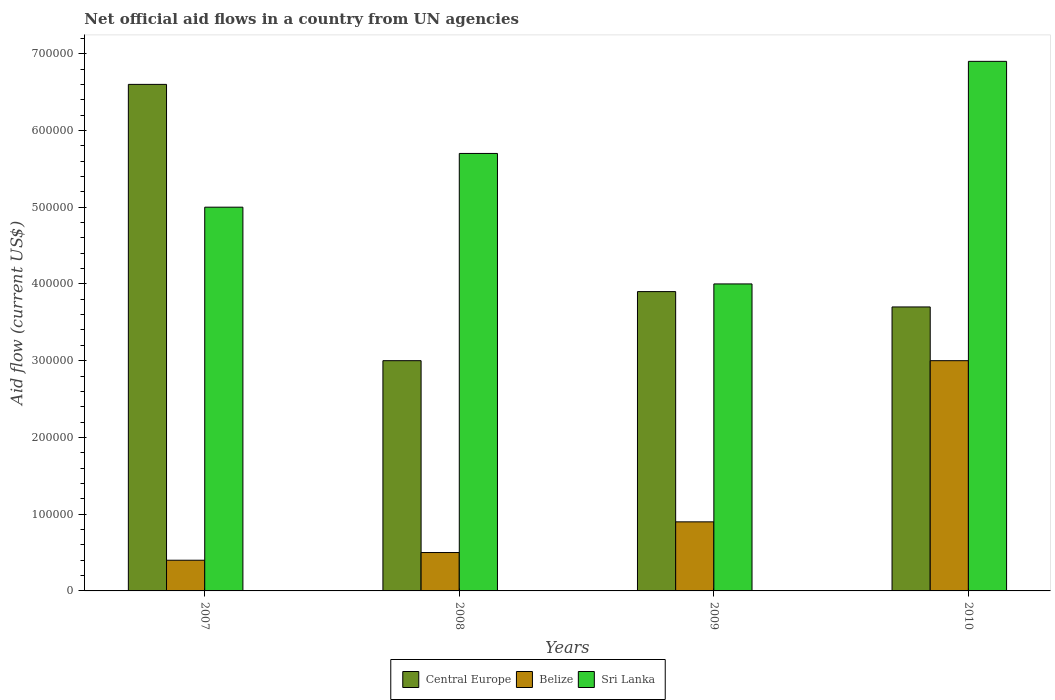How many groups of bars are there?
Give a very brief answer. 4. Are the number of bars per tick equal to the number of legend labels?
Offer a very short reply. Yes. How many bars are there on the 2nd tick from the left?
Offer a very short reply. 3. How many bars are there on the 1st tick from the right?
Keep it short and to the point. 3. What is the net official aid flow in Belize in 2008?
Offer a very short reply. 5.00e+04. Across all years, what is the maximum net official aid flow in Belize?
Give a very brief answer. 3.00e+05. Across all years, what is the minimum net official aid flow in Belize?
Your answer should be very brief. 4.00e+04. In which year was the net official aid flow in Belize maximum?
Offer a very short reply. 2010. In which year was the net official aid flow in Central Europe minimum?
Provide a succinct answer. 2008. What is the total net official aid flow in Central Europe in the graph?
Ensure brevity in your answer.  1.72e+06. What is the difference between the net official aid flow in Belize in 2009 and that in 2010?
Your answer should be compact. -2.10e+05. What is the difference between the net official aid flow in Central Europe in 2008 and the net official aid flow in Sri Lanka in 2010?
Offer a terse response. -3.90e+05. What is the average net official aid flow in Sri Lanka per year?
Give a very brief answer. 5.40e+05. What is the ratio of the net official aid flow in Belize in 2007 to that in 2010?
Provide a short and direct response. 0.13. Is the difference between the net official aid flow in Sri Lanka in 2008 and 2009 greater than the difference between the net official aid flow in Central Europe in 2008 and 2009?
Keep it short and to the point. Yes. What is the difference between the highest and the second highest net official aid flow in Central Europe?
Your response must be concise. 2.70e+05. What is the difference between the highest and the lowest net official aid flow in Central Europe?
Provide a succinct answer. 3.60e+05. Is the sum of the net official aid flow in Belize in 2008 and 2009 greater than the maximum net official aid flow in Central Europe across all years?
Ensure brevity in your answer.  No. What does the 2nd bar from the left in 2009 represents?
Provide a short and direct response. Belize. What does the 3rd bar from the right in 2010 represents?
Make the answer very short. Central Europe. Is it the case that in every year, the sum of the net official aid flow in Belize and net official aid flow in Sri Lanka is greater than the net official aid flow in Central Europe?
Your response must be concise. No. How many bars are there?
Provide a short and direct response. 12. Are all the bars in the graph horizontal?
Make the answer very short. No. Where does the legend appear in the graph?
Provide a succinct answer. Bottom center. How many legend labels are there?
Ensure brevity in your answer.  3. How are the legend labels stacked?
Your answer should be compact. Horizontal. What is the title of the graph?
Make the answer very short. Net official aid flows in a country from UN agencies. What is the label or title of the X-axis?
Provide a short and direct response. Years. What is the Aid flow (current US$) in Central Europe in 2007?
Offer a very short reply. 6.60e+05. What is the Aid flow (current US$) in Belize in 2007?
Your answer should be compact. 4.00e+04. What is the Aid flow (current US$) in Sri Lanka in 2007?
Your response must be concise. 5.00e+05. What is the Aid flow (current US$) in Central Europe in 2008?
Ensure brevity in your answer.  3.00e+05. What is the Aid flow (current US$) of Sri Lanka in 2008?
Your answer should be compact. 5.70e+05. What is the Aid flow (current US$) of Central Europe in 2009?
Your response must be concise. 3.90e+05. What is the Aid flow (current US$) in Belize in 2009?
Your answer should be compact. 9.00e+04. What is the Aid flow (current US$) of Sri Lanka in 2009?
Keep it short and to the point. 4.00e+05. What is the Aid flow (current US$) of Sri Lanka in 2010?
Provide a short and direct response. 6.90e+05. Across all years, what is the maximum Aid flow (current US$) in Central Europe?
Ensure brevity in your answer.  6.60e+05. Across all years, what is the maximum Aid flow (current US$) of Belize?
Offer a very short reply. 3.00e+05. Across all years, what is the maximum Aid flow (current US$) of Sri Lanka?
Your answer should be compact. 6.90e+05. Across all years, what is the minimum Aid flow (current US$) in Belize?
Ensure brevity in your answer.  4.00e+04. What is the total Aid flow (current US$) of Central Europe in the graph?
Your answer should be compact. 1.72e+06. What is the total Aid flow (current US$) of Belize in the graph?
Make the answer very short. 4.80e+05. What is the total Aid flow (current US$) in Sri Lanka in the graph?
Give a very brief answer. 2.16e+06. What is the difference between the Aid flow (current US$) of Central Europe in 2007 and that in 2008?
Make the answer very short. 3.60e+05. What is the difference between the Aid flow (current US$) in Belize in 2007 and that in 2008?
Offer a terse response. -10000. What is the difference between the Aid flow (current US$) in Belize in 2007 and that in 2009?
Provide a short and direct response. -5.00e+04. What is the difference between the Aid flow (current US$) in Sri Lanka in 2007 and that in 2009?
Provide a short and direct response. 1.00e+05. What is the difference between the Aid flow (current US$) of Central Europe in 2007 and that in 2010?
Give a very brief answer. 2.90e+05. What is the difference between the Aid flow (current US$) of Belize in 2007 and that in 2010?
Offer a very short reply. -2.60e+05. What is the difference between the Aid flow (current US$) of Sri Lanka in 2007 and that in 2010?
Make the answer very short. -1.90e+05. What is the difference between the Aid flow (current US$) in Belize in 2008 and that in 2009?
Your response must be concise. -4.00e+04. What is the difference between the Aid flow (current US$) in Sri Lanka in 2008 and that in 2010?
Provide a succinct answer. -1.20e+05. What is the difference between the Aid flow (current US$) of Central Europe in 2007 and the Aid flow (current US$) of Sri Lanka in 2008?
Your answer should be compact. 9.00e+04. What is the difference between the Aid flow (current US$) of Belize in 2007 and the Aid flow (current US$) of Sri Lanka in 2008?
Provide a succinct answer. -5.30e+05. What is the difference between the Aid flow (current US$) of Central Europe in 2007 and the Aid flow (current US$) of Belize in 2009?
Provide a short and direct response. 5.70e+05. What is the difference between the Aid flow (current US$) of Central Europe in 2007 and the Aid flow (current US$) of Sri Lanka in 2009?
Provide a short and direct response. 2.60e+05. What is the difference between the Aid flow (current US$) in Belize in 2007 and the Aid flow (current US$) in Sri Lanka in 2009?
Give a very brief answer. -3.60e+05. What is the difference between the Aid flow (current US$) in Central Europe in 2007 and the Aid flow (current US$) in Belize in 2010?
Offer a very short reply. 3.60e+05. What is the difference between the Aid flow (current US$) of Belize in 2007 and the Aid flow (current US$) of Sri Lanka in 2010?
Your response must be concise. -6.50e+05. What is the difference between the Aid flow (current US$) of Central Europe in 2008 and the Aid flow (current US$) of Sri Lanka in 2009?
Your response must be concise. -1.00e+05. What is the difference between the Aid flow (current US$) in Belize in 2008 and the Aid flow (current US$) in Sri Lanka in 2009?
Ensure brevity in your answer.  -3.50e+05. What is the difference between the Aid flow (current US$) in Central Europe in 2008 and the Aid flow (current US$) in Sri Lanka in 2010?
Your response must be concise. -3.90e+05. What is the difference between the Aid flow (current US$) of Belize in 2008 and the Aid flow (current US$) of Sri Lanka in 2010?
Your response must be concise. -6.40e+05. What is the difference between the Aid flow (current US$) of Central Europe in 2009 and the Aid flow (current US$) of Sri Lanka in 2010?
Provide a succinct answer. -3.00e+05. What is the difference between the Aid flow (current US$) of Belize in 2009 and the Aid flow (current US$) of Sri Lanka in 2010?
Provide a short and direct response. -6.00e+05. What is the average Aid flow (current US$) in Central Europe per year?
Your response must be concise. 4.30e+05. What is the average Aid flow (current US$) in Sri Lanka per year?
Provide a short and direct response. 5.40e+05. In the year 2007, what is the difference between the Aid flow (current US$) of Central Europe and Aid flow (current US$) of Belize?
Provide a short and direct response. 6.20e+05. In the year 2007, what is the difference between the Aid flow (current US$) of Belize and Aid flow (current US$) of Sri Lanka?
Offer a terse response. -4.60e+05. In the year 2008, what is the difference between the Aid flow (current US$) of Central Europe and Aid flow (current US$) of Belize?
Your answer should be compact. 2.50e+05. In the year 2008, what is the difference between the Aid flow (current US$) of Belize and Aid flow (current US$) of Sri Lanka?
Provide a succinct answer. -5.20e+05. In the year 2009, what is the difference between the Aid flow (current US$) of Central Europe and Aid flow (current US$) of Belize?
Your answer should be compact. 3.00e+05. In the year 2009, what is the difference between the Aid flow (current US$) in Central Europe and Aid flow (current US$) in Sri Lanka?
Offer a very short reply. -10000. In the year 2009, what is the difference between the Aid flow (current US$) in Belize and Aid flow (current US$) in Sri Lanka?
Your answer should be compact. -3.10e+05. In the year 2010, what is the difference between the Aid flow (current US$) in Central Europe and Aid flow (current US$) in Belize?
Keep it short and to the point. 7.00e+04. In the year 2010, what is the difference between the Aid flow (current US$) in Central Europe and Aid flow (current US$) in Sri Lanka?
Make the answer very short. -3.20e+05. In the year 2010, what is the difference between the Aid flow (current US$) in Belize and Aid flow (current US$) in Sri Lanka?
Give a very brief answer. -3.90e+05. What is the ratio of the Aid flow (current US$) in Sri Lanka in 2007 to that in 2008?
Give a very brief answer. 0.88. What is the ratio of the Aid flow (current US$) in Central Europe in 2007 to that in 2009?
Make the answer very short. 1.69. What is the ratio of the Aid flow (current US$) in Belize in 2007 to that in 2009?
Provide a succinct answer. 0.44. What is the ratio of the Aid flow (current US$) of Sri Lanka in 2007 to that in 2009?
Your answer should be very brief. 1.25. What is the ratio of the Aid flow (current US$) of Central Europe in 2007 to that in 2010?
Your response must be concise. 1.78. What is the ratio of the Aid flow (current US$) in Belize in 2007 to that in 2010?
Your answer should be compact. 0.13. What is the ratio of the Aid flow (current US$) in Sri Lanka in 2007 to that in 2010?
Offer a terse response. 0.72. What is the ratio of the Aid flow (current US$) of Central Europe in 2008 to that in 2009?
Make the answer very short. 0.77. What is the ratio of the Aid flow (current US$) in Belize in 2008 to that in 2009?
Your answer should be very brief. 0.56. What is the ratio of the Aid flow (current US$) of Sri Lanka in 2008 to that in 2009?
Make the answer very short. 1.43. What is the ratio of the Aid flow (current US$) of Central Europe in 2008 to that in 2010?
Make the answer very short. 0.81. What is the ratio of the Aid flow (current US$) of Belize in 2008 to that in 2010?
Ensure brevity in your answer.  0.17. What is the ratio of the Aid flow (current US$) of Sri Lanka in 2008 to that in 2010?
Offer a very short reply. 0.83. What is the ratio of the Aid flow (current US$) in Central Europe in 2009 to that in 2010?
Provide a succinct answer. 1.05. What is the ratio of the Aid flow (current US$) of Belize in 2009 to that in 2010?
Offer a very short reply. 0.3. What is the ratio of the Aid flow (current US$) in Sri Lanka in 2009 to that in 2010?
Keep it short and to the point. 0.58. What is the difference between the highest and the second highest Aid flow (current US$) of Central Europe?
Keep it short and to the point. 2.70e+05. What is the difference between the highest and the second highest Aid flow (current US$) of Belize?
Ensure brevity in your answer.  2.10e+05. What is the difference between the highest and the second highest Aid flow (current US$) in Sri Lanka?
Your response must be concise. 1.20e+05. What is the difference between the highest and the lowest Aid flow (current US$) in Central Europe?
Ensure brevity in your answer.  3.60e+05. 